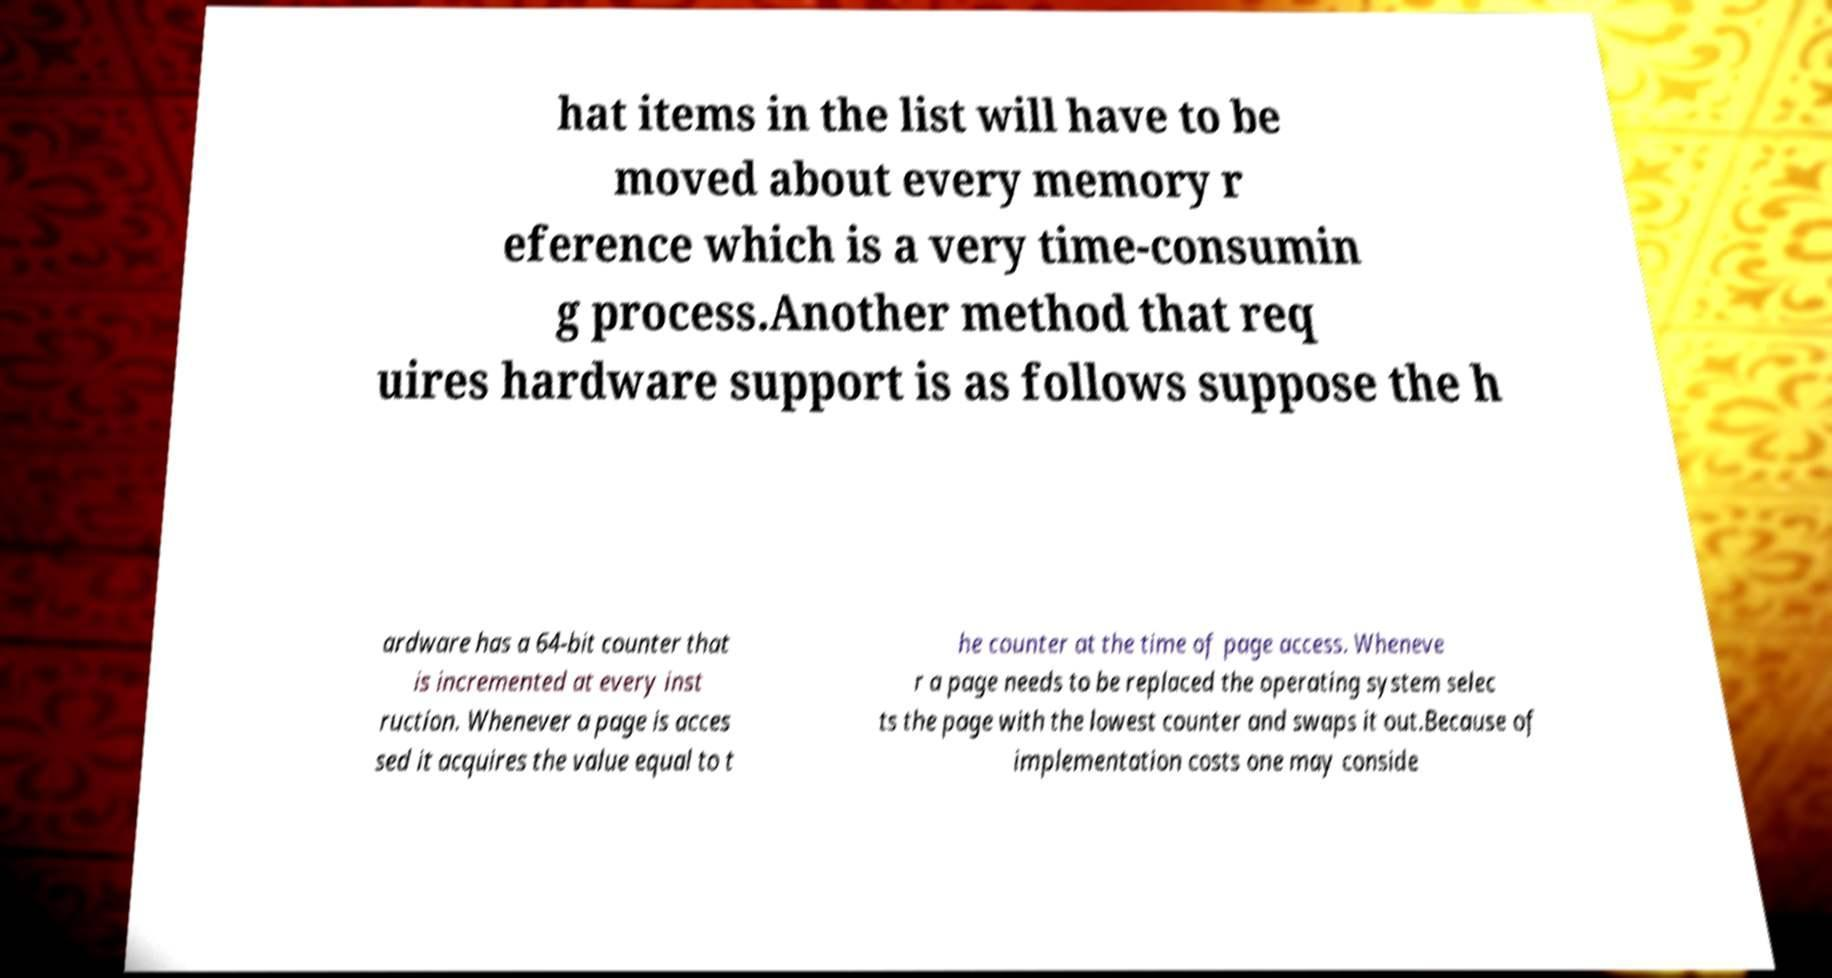There's text embedded in this image that I need extracted. Can you transcribe it verbatim? hat items in the list will have to be moved about every memory r eference which is a very time-consumin g process.Another method that req uires hardware support is as follows suppose the h ardware has a 64-bit counter that is incremented at every inst ruction. Whenever a page is acces sed it acquires the value equal to t he counter at the time of page access. Wheneve r a page needs to be replaced the operating system selec ts the page with the lowest counter and swaps it out.Because of implementation costs one may conside 